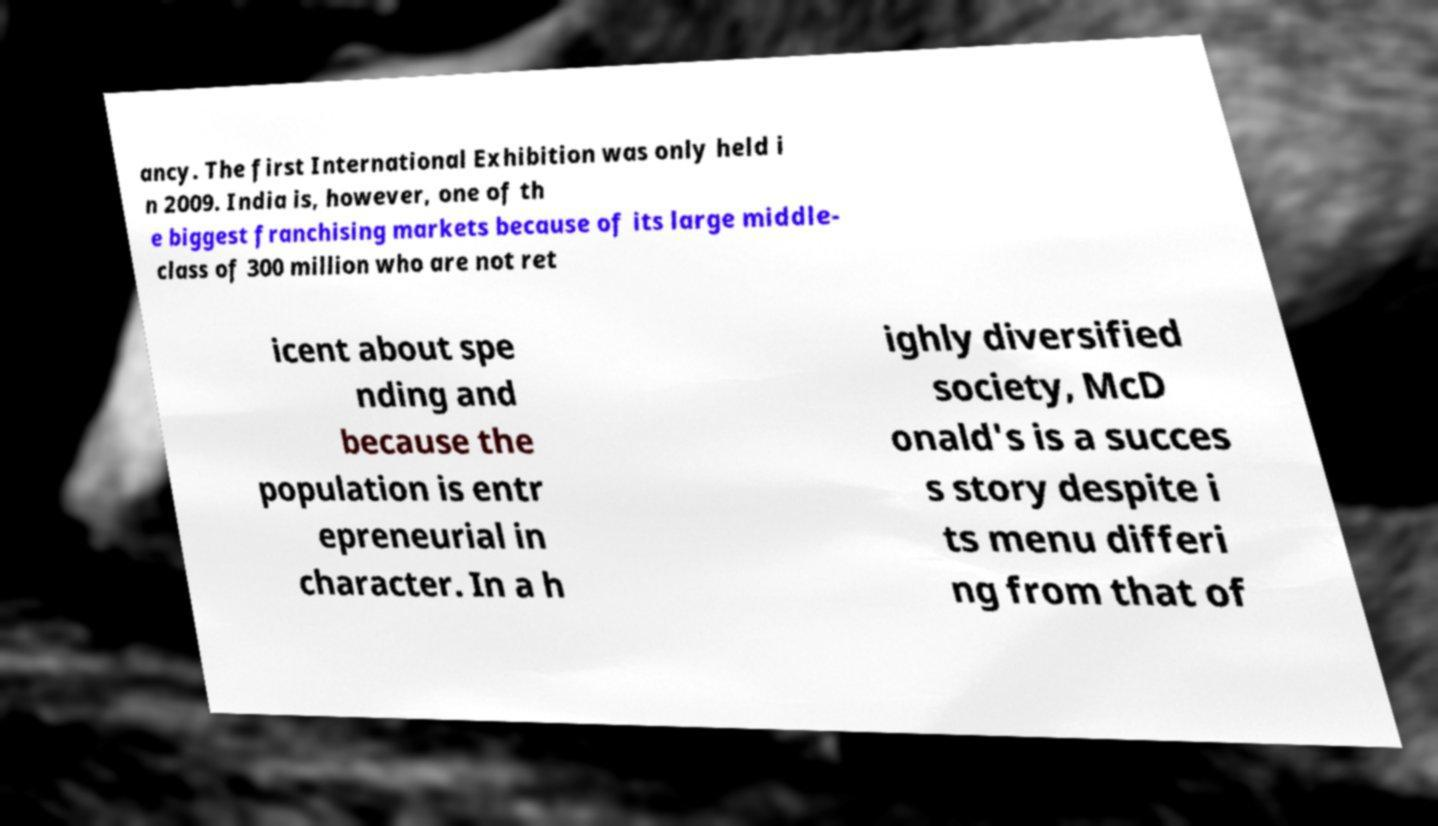Please read and relay the text visible in this image. What does it say? ancy. The first International Exhibition was only held i n 2009. India is, however, one of th e biggest franchising markets because of its large middle- class of 300 million who are not ret icent about spe nding and because the population is entr epreneurial in character. In a h ighly diversified society, McD onald's is a succes s story despite i ts menu differi ng from that of 